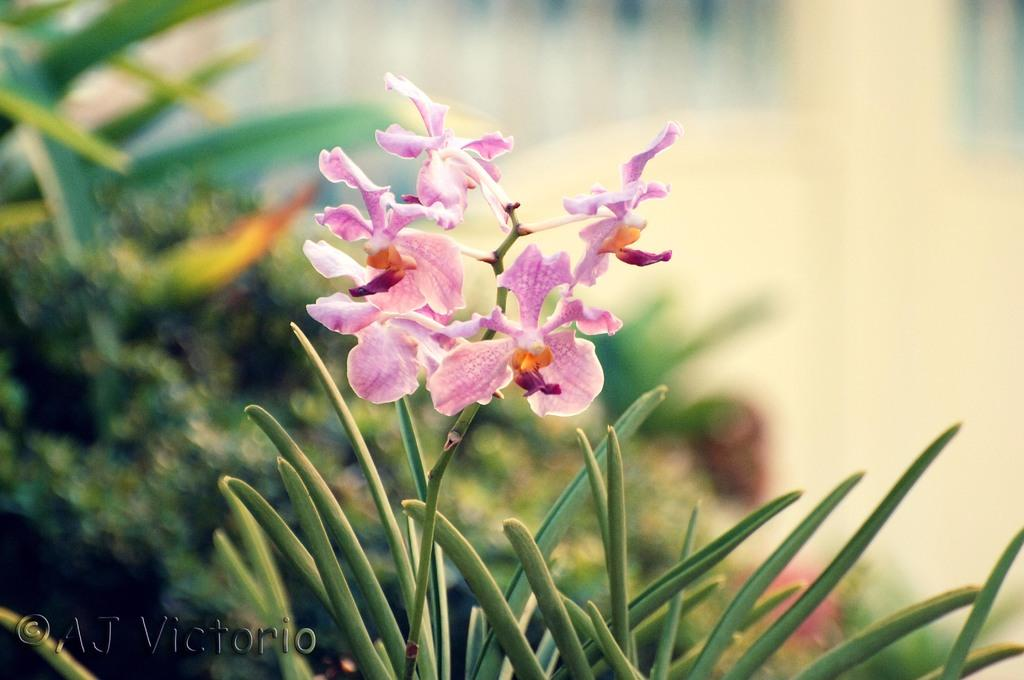What is located in the foreground of the picture? There is a plant and flowers in the foreground of the picture. Can you describe the background of the image? The background of the image is blurred. What else can be seen in the foreground of the picture besides the plant and flowers? There is no other information provided about the foreground. What type of vegetation is visible in the background of the image? There are plants in the background of the image. How many trucks are being served by the plant in the image? There is no truck or servant present in the image; it features a plant and flowers in the foreground and a blurred background. 